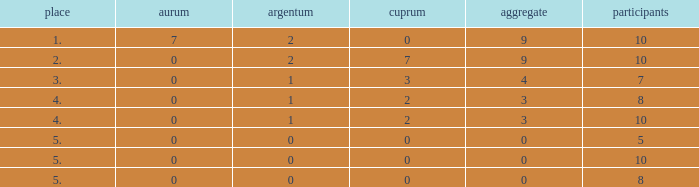What is listed as the highest Gold that also has a Silver that's smaller than 1, and has a Total that's smaller than 0? None. 